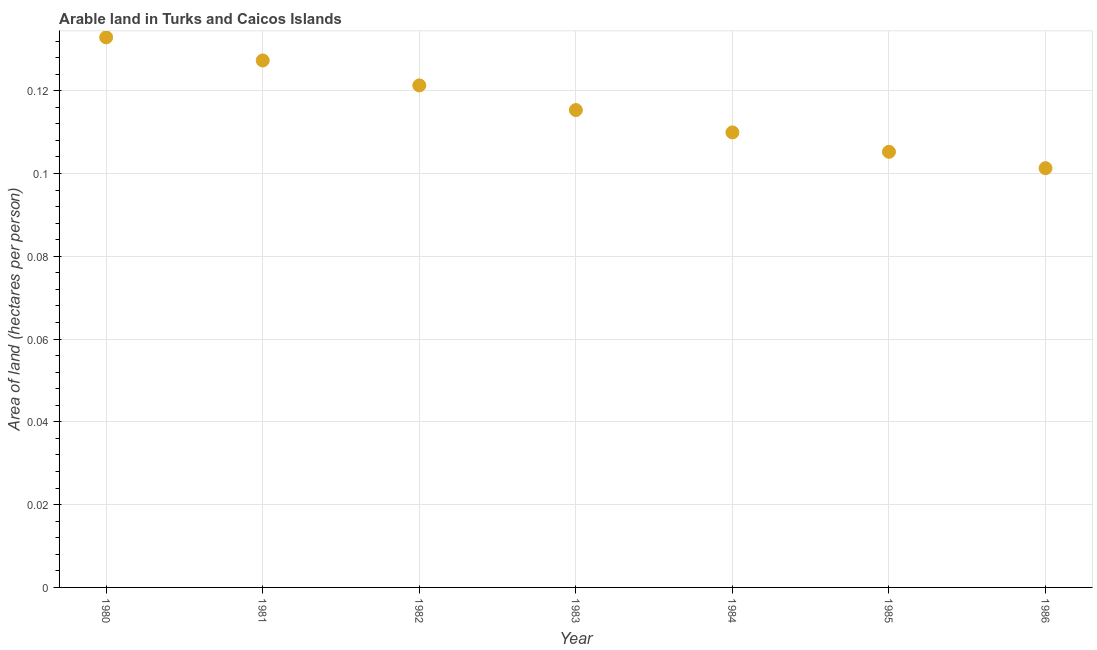What is the area of arable land in 1982?
Give a very brief answer. 0.12. Across all years, what is the maximum area of arable land?
Provide a short and direct response. 0.13. Across all years, what is the minimum area of arable land?
Keep it short and to the point. 0.1. What is the sum of the area of arable land?
Your answer should be very brief. 0.81. What is the difference between the area of arable land in 1980 and 1984?
Provide a succinct answer. 0.02. What is the average area of arable land per year?
Offer a terse response. 0.12. What is the median area of arable land?
Your answer should be compact. 0.12. In how many years, is the area of arable land greater than 0.024 hectares per person?
Make the answer very short. 7. What is the ratio of the area of arable land in 1985 to that in 1986?
Make the answer very short. 1.04. Is the area of arable land in 1980 less than that in 1985?
Your response must be concise. No. Is the difference between the area of arable land in 1982 and 1986 greater than the difference between any two years?
Offer a terse response. No. What is the difference between the highest and the second highest area of arable land?
Your response must be concise. 0.01. What is the difference between the highest and the lowest area of arable land?
Offer a terse response. 0.03. In how many years, is the area of arable land greater than the average area of arable land taken over all years?
Keep it short and to the point. 3. How many years are there in the graph?
Your answer should be very brief. 7. What is the difference between two consecutive major ticks on the Y-axis?
Provide a short and direct response. 0.02. Are the values on the major ticks of Y-axis written in scientific E-notation?
Offer a very short reply. No. Does the graph contain grids?
Keep it short and to the point. Yes. What is the title of the graph?
Offer a terse response. Arable land in Turks and Caicos Islands. What is the label or title of the Y-axis?
Provide a short and direct response. Area of land (hectares per person). What is the Area of land (hectares per person) in 1980?
Ensure brevity in your answer.  0.13. What is the Area of land (hectares per person) in 1981?
Ensure brevity in your answer.  0.13. What is the Area of land (hectares per person) in 1982?
Your response must be concise. 0.12. What is the Area of land (hectares per person) in 1983?
Your answer should be compact. 0.12. What is the Area of land (hectares per person) in 1984?
Provide a short and direct response. 0.11. What is the Area of land (hectares per person) in 1985?
Offer a very short reply. 0.11. What is the Area of land (hectares per person) in 1986?
Provide a succinct answer. 0.1. What is the difference between the Area of land (hectares per person) in 1980 and 1981?
Your response must be concise. 0.01. What is the difference between the Area of land (hectares per person) in 1980 and 1982?
Keep it short and to the point. 0.01. What is the difference between the Area of land (hectares per person) in 1980 and 1983?
Your answer should be compact. 0.02. What is the difference between the Area of land (hectares per person) in 1980 and 1984?
Offer a terse response. 0.02. What is the difference between the Area of land (hectares per person) in 1980 and 1985?
Give a very brief answer. 0.03. What is the difference between the Area of land (hectares per person) in 1980 and 1986?
Provide a succinct answer. 0.03. What is the difference between the Area of land (hectares per person) in 1981 and 1982?
Ensure brevity in your answer.  0.01. What is the difference between the Area of land (hectares per person) in 1981 and 1983?
Ensure brevity in your answer.  0.01. What is the difference between the Area of land (hectares per person) in 1981 and 1984?
Keep it short and to the point. 0.02. What is the difference between the Area of land (hectares per person) in 1981 and 1985?
Keep it short and to the point. 0.02. What is the difference between the Area of land (hectares per person) in 1981 and 1986?
Your answer should be very brief. 0.03. What is the difference between the Area of land (hectares per person) in 1982 and 1983?
Provide a succinct answer. 0.01. What is the difference between the Area of land (hectares per person) in 1982 and 1984?
Your response must be concise. 0.01. What is the difference between the Area of land (hectares per person) in 1982 and 1985?
Your answer should be compact. 0.02. What is the difference between the Area of land (hectares per person) in 1982 and 1986?
Provide a succinct answer. 0.02. What is the difference between the Area of land (hectares per person) in 1983 and 1984?
Offer a very short reply. 0.01. What is the difference between the Area of land (hectares per person) in 1983 and 1985?
Offer a very short reply. 0.01. What is the difference between the Area of land (hectares per person) in 1983 and 1986?
Your answer should be compact. 0.01. What is the difference between the Area of land (hectares per person) in 1984 and 1985?
Offer a terse response. 0. What is the difference between the Area of land (hectares per person) in 1984 and 1986?
Provide a succinct answer. 0.01. What is the difference between the Area of land (hectares per person) in 1985 and 1986?
Provide a short and direct response. 0. What is the ratio of the Area of land (hectares per person) in 1980 to that in 1981?
Your answer should be compact. 1.04. What is the ratio of the Area of land (hectares per person) in 1980 to that in 1982?
Your answer should be very brief. 1.1. What is the ratio of the Area of land (hectares per person) in 1980 to that in 1983?
Ensure brevity in your answer.  1.15. What is the ratio of the Area of land (hectares per person) in 1980 to that in 1984?
Your answer should be very brief. 1.21. What is the ratio of the Area of land (hectares per person) in 1980 to that in 1985?
Keep it short and to the point. 1.26. What is the ratio of the Area of land (hectares per person) in 1980 to that in 1986?
Provide a short and direct response. 1.31. What is the ratio of the Area of land (hectares per person) in 1981 to that in 1983?
Make the answer very short. 1.1. What is the ratio of the Area of land (hectares per person) in 1981 to that in 1984?
Ensure brevity in your answer.  1.16. What is the ratio of the Area of land (hectares per person) in 1981 to that in 1985?
Your response must be concise. 1.21. What is the ratio of the Area of land (hectares per person) in 1981 to that in 1986?
Provide a succinct answer. 1.26. What is the ratio of the Area of land (hectares per person) in 1982 to that in 1983?
Offer a very short reply. 1.05. What is the ratio of the Area of land (hectares per person) in 1982 to that in 1984?
Provide a succinct answer. 1.1. What is the ratio of the Area of land (hectares per person) in 1982 to that in 1985?
Your answer should be compact. 1.15. What is the ratio of the Area of land (hectares per person) in 1982 to that in 1986?
Provide a succinct answer. 1.2. What is the ratio of the Area of land (hectares per person) in 1983 to that in 1984?
Keep it short and to the point. 1.05. What is the ratio of the Area of land (hectares per person) in 1983 to that in 1985?
Ensure brevity in your answer.  1.1. What is the ratio of the Area of land (hectares per person) in 1983 to that in 1986?
Give a very brief answer. 1.14. What is the ratio of the Area of land (hectares per person) in 1984 to that in 1985?
Provide a succinct answer. 1.04. What is the ratio of the Area of land (hectares per person) in 1984 to that in 1986?
Keep it short and to the point. 1.08. What is the ratio of the Area of land (hectares per person) in 1985 to that in 1986?
Provide a succinct answer. 1.04. 